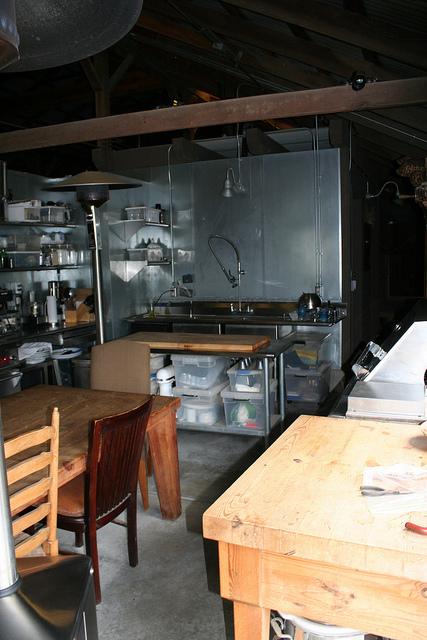Is there any metal?
Concise answer only. Yes. Do the chairs match?
Keep it brief. No. How many chairs are in the image?
Answer briefly. 2. 